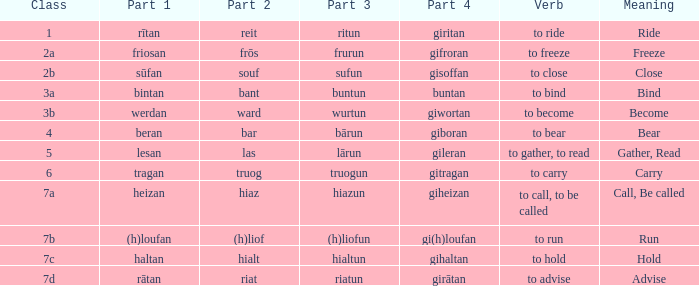What is the part 4 of the word with the part 1 "heizan"? Giheizan. 